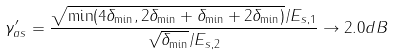Convert formula to latex. <formula><loc_0><loc_0><loc_500><loc_500>\gamma ^ { \prime } _ { a s } = \frac { \sqrt { \min ( 4 \delta _ { \min } , 2 \delta _ { \min } + \delta _ { \min } + 2 \delta _ { \min } ) } / E _ { s , 1 } } { \sqrt { \delta _ { \min } } / E _ { s , 2 } } \rightarrow 2 . 0 d B</formula> 